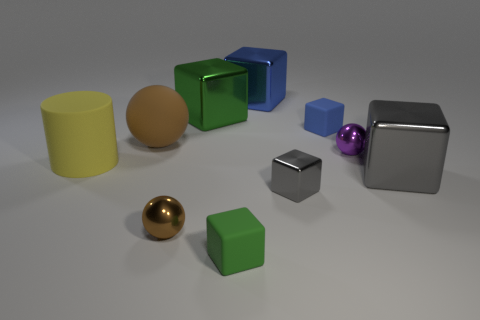Subtract all tiny metallic cubes. How many cubes are left? 5 Subtract all blue cubes. How many brown spheres are left? 2 Subtract 1 spheres. How many spheres are left? 2 Subtract all blue cubes. How many cubes are left? 4 Subtract all blocks. How many objects are left? 4 Subtract all gray cubes. Subtract all cyan spheres. How many cubes are left? 4 Subtract all large green things. Subtract all large yellow things. How many objects are left? 8 Add 6 gray metal things. How many gray metal things are left? 8 Add 6 cylinders. How many cylinders exist? 7 Subtract 0 cyan spheres. How many objects are left? 10 